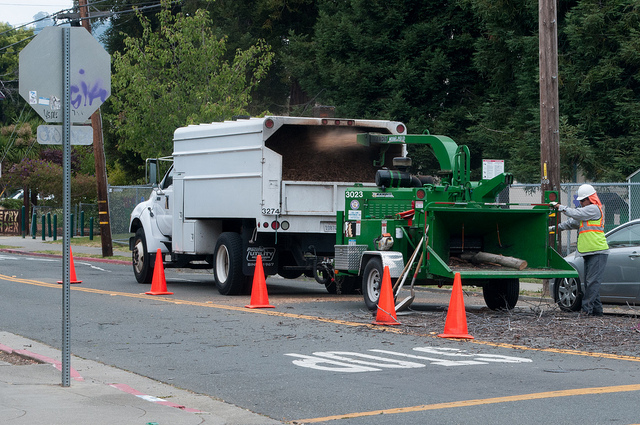Identify and read out the text in this image. 3274 3023 STOP ETRY 